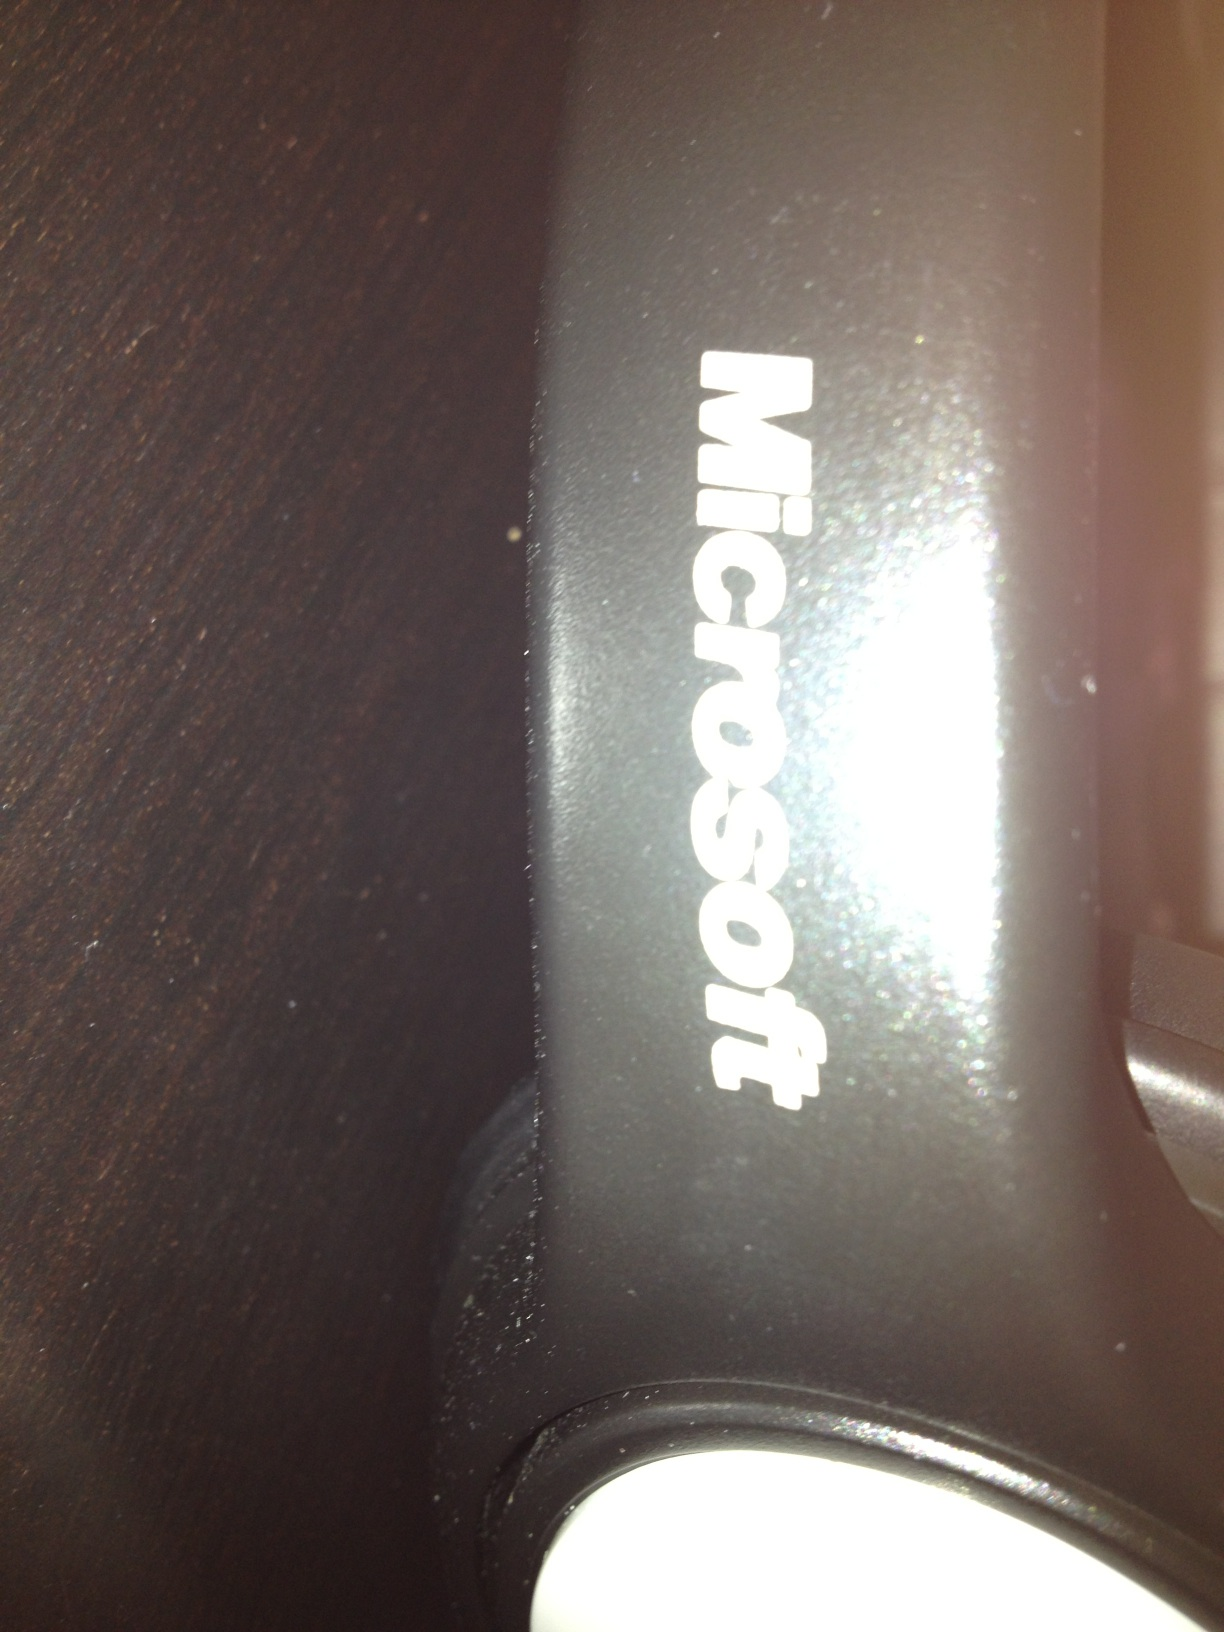Can you tell what kind of object the Microsoft logo is displayed on? The Microsoft logo appears on what might be a peripheral device, perhaps part of a computer or related accessory. The exact type of object is not clearly identifiable from the image provided. 